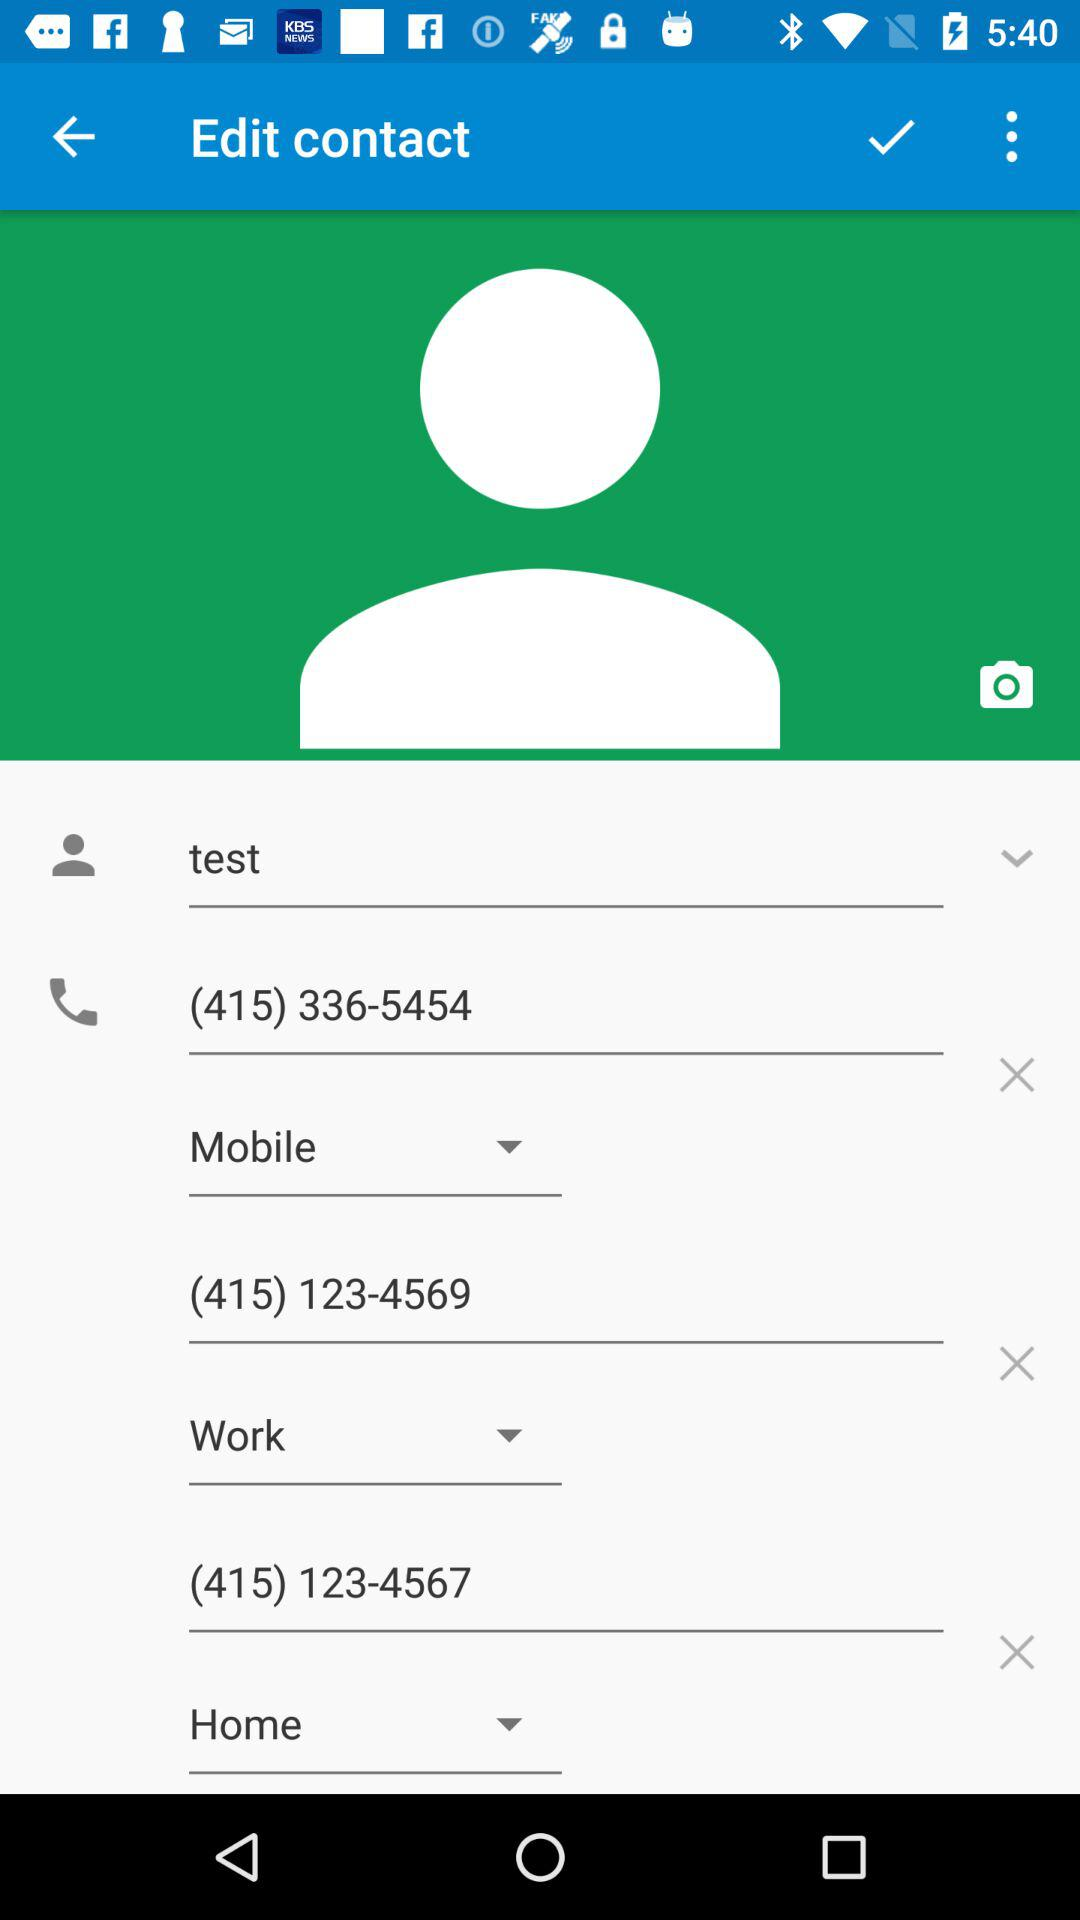What is the work phone number? The work phone number is (415) 123-4567. 